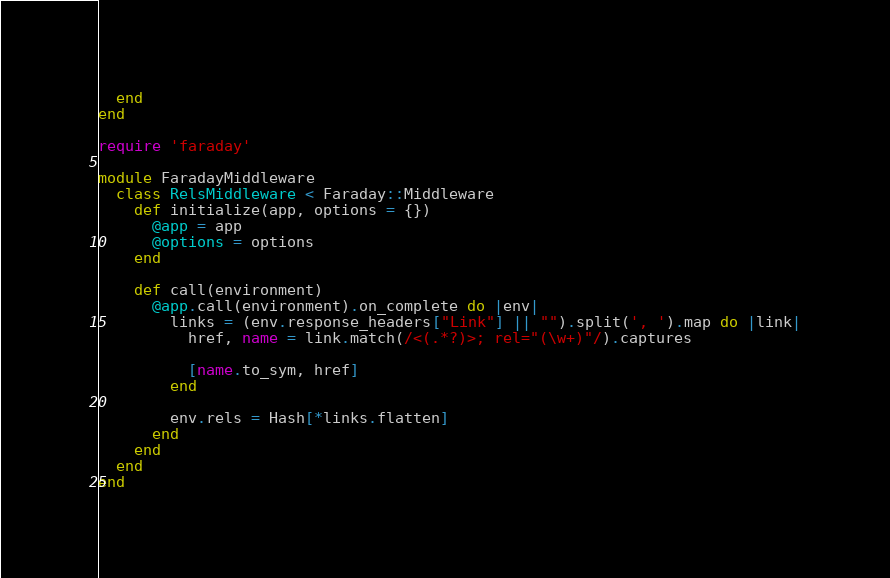<code> <loc_0><loc_0><loc_500><loc_500><_Ruby_>  end
end

require 'faraday'

module FaradayMiddleware
  class RelsMiddleware < Faraday::Middleware
    def initialize(app, options = {})
      @app = app
      @options = options
    end

    def call(environment)
      @app.call(environment).on_complete do |env|
        links = (env.response_headers["Link"] || "").split(', ').map do |link|
          href, name = link.match(/<(.*?)>; rel="(\w+)"/).captures

          [name.to_sym, href]
        end

        env.rels = Hash[*links.flatten]
      end
    end
  end
end
</code> 